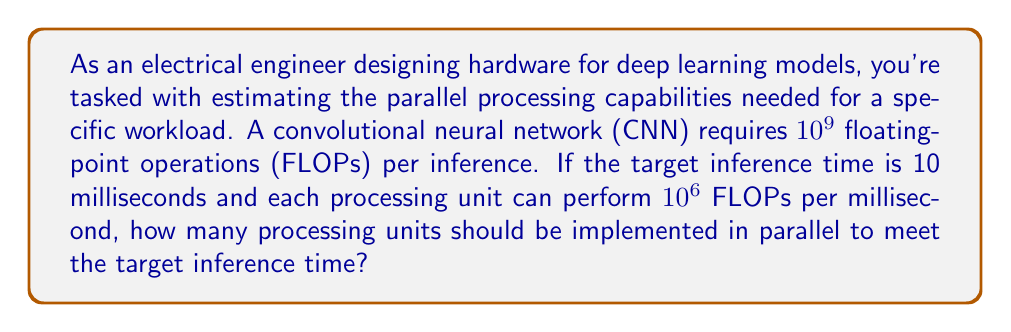Solve this math problem. To solve this problem, we need to follow these steps:

1. Calculate the total number of FLOPs required per second:
   $$\text{FLOPs per second} = \frac{\text{FLOPs per inference}}{\text{Inference time in seconds}}$$
   $$\text{FLOPs per second} = \frac{10^9}{10 \times 10^{-3}} = 10^{11} \text{ FLOPs/s}$$

2. Calculate the number of FLOPs a single processing unit can perform per second:
   $$\text{FLOPs per unit per second} = 10^6 \text{ FLOPs/ms} \times 1000 \text{ ms/s} = 10^9 \text{ FLOPs/s}$$

3. Calculate the number of processing units needed:
   $$\text{Number of units} = \frac{\text{Required FLOPs per second}}{\text{FLOPs per unit per second}}$$
   $$\text{Number of units} = \frac{10^{11}}{10^9} = 100$$

Therefore, 100 processing units should be implemented in parallel to meet the target inference time.
Answer: 100 processing units 